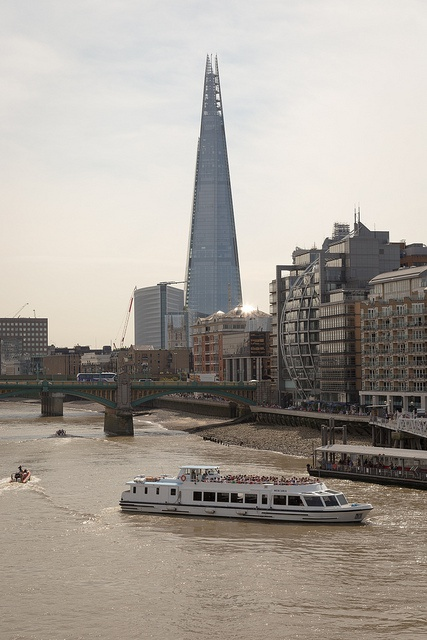Describe the objects in this image and their specific colors. I can see boat in lightgray, gray, and black tones, people in lightgray, black, gray, and darkgray tones, boat in lightgray, black, gray, and darkgray tones, bus in lightgray, black, gray, and darkgray tones, and bus in lightgray, gray, and maroon tones in this image. 